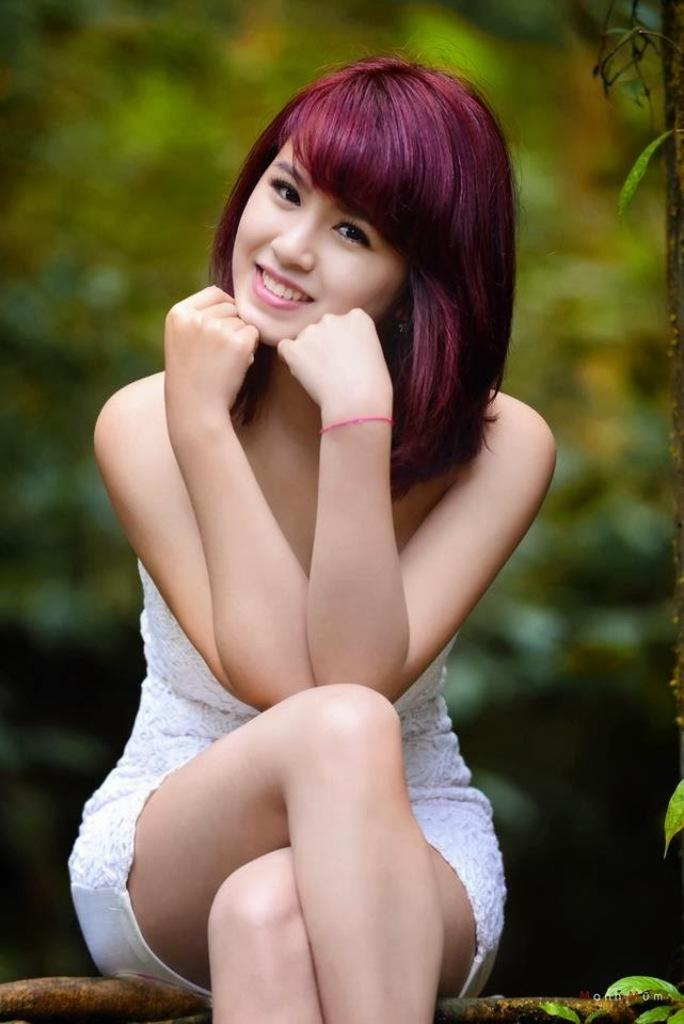What is the girl doing in the image? The girl is sitting in the image. What can be seen in the background of the image? There are trees in the background of the image. What type of vegetation is on the right side of the image? There are leaves on the right side of the image. What is the name of the cloud in the image? There is no cloud present in the image, so it is not possible to determine the name of a cloud. 